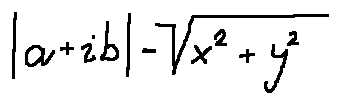Convert formula to latex. <formula><loc_0><loc_0><loc_500><loc_500>| a + i b | = \sqrt { x ^ { 2 } + y ^ { 2 } }</formula> 